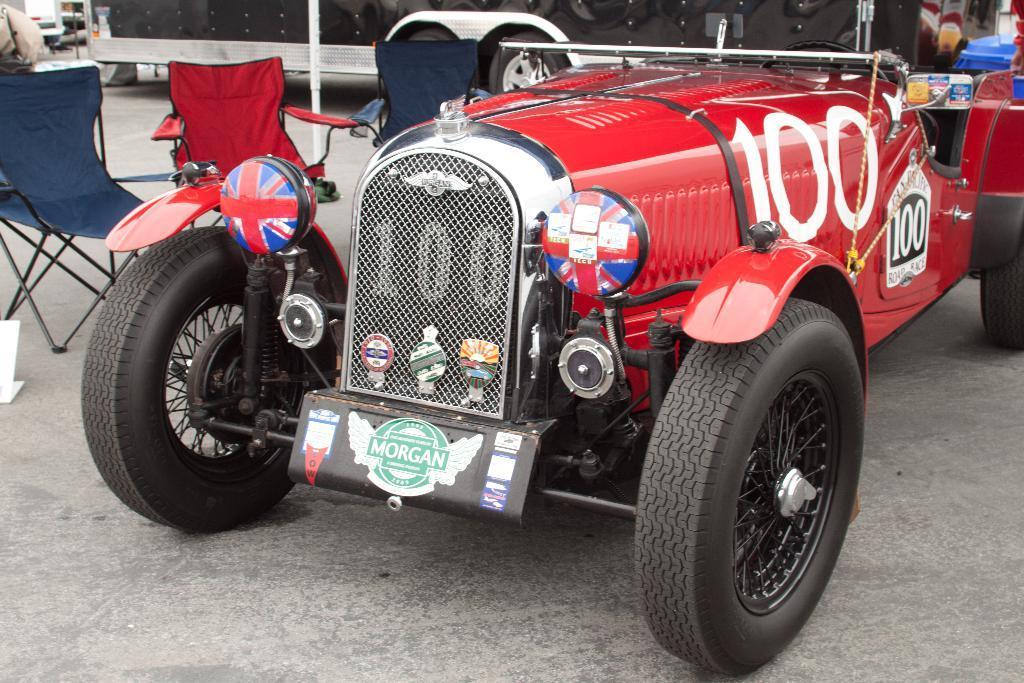Could you give a brief overview of what you see in this image? In this picture I can see some vehicles, chairs are placed on the ground. 